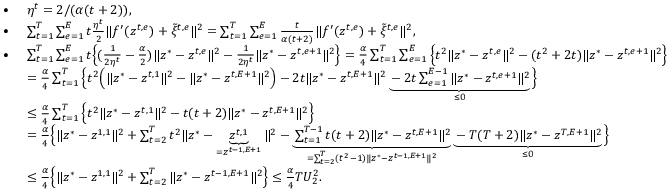<formula> <loc_0><loc_0><loc_500><loc_500>\begin{array} { r l } { \bullet \ } & { \eta ^ { t } = 2 / ( \alpha ( t + 2 ) ) , } \\ { \bullet \ } & { \sum _ { t = 1 } ^ { T } \sum _ { e = 1 } ^ { E } t \frac { \eta ^ { t } } { 2 } \| f ^ { \prime } ( z ^ { t , e } ) + \tilde { \xi } ^ { t , e } \| ^ { 2 } = \sum _ { t = 1 } ^ { T } \sum _ { e = 1 } ^ { E } \frac { t } { \alpha ( t + 2 ) } \| f ^ { \prime } ( z ^ { t , e } ) + \tilde { \xi } ^ { t , e } \| ^ { 2 } , } \\ { \bullet \ } & { \sum _ { t = 1 } ^ { T } \sum _ { e = 1 } ^ { E } t \left \{ ( \frac { 1 } { 2 \eta ^ { t } } - \frac { \alpha } { 2 } ) \| z ^ { * } - z ^ { t , e } \| ^ { 2 } - \frac { 1 } { 2 \eta ^ { t } } \| z ^ { * } - z ^ { t , e + 1 } \| ^ { 2 } \right \} = \frac { \alpha } { 4 } \sum _ { t = 1 } ^ { T } \sum _ { e = 1 } ^ { E } \left \{ t ^ { 2 } \| z ^ { * } - z ^ { t , e } \| ^ { 2 } - ( t ^ { 2 } + 2 t ) \| z ^ { * } - z ^ { t , e + 1 } \| ^ { 2 } \right \} } \\ & { = \frac { \alpha } { 4 } \sum _ { t = 1 } ^ { T } \left \{ t ^ { 2 } \left ( \| z ^ { * } - z ^ { t , 1 } \| ^ { 2 } - \| z ^ { * } - z ^ { t , E + 1 } \| ^ { 2 } \right ) - 2 t \| z ^ { * } - z ^ { t , E + 1 } \| ^ { 2 } \underbrace { - 2 t \sum _ { e = 1 } ^ { E - 1 } \| z ^ { * } - z ^ { t , e + 1 } \| ^ { 2 } } _ { \leq 0 } \right \} } \\ & { \leq \frac { \alpha } { 4 } \sum _ { t = 1 } ^ { T } \left \{ t ^ { 2 } \| z ^ { * } - z ^ { t , 1 } \| ^ { 2 } - t ( t + 2 ) \| z ^ { * } - z ^ { t , E + 1 } \| ^ { 2 } \right \} } \\ & { = \frac { \alpha } { 4 } \left \{ \| z ^ { * } - z ^ { 1 , 1 } \| ^ { 2 } + \sum _ { t = 2 } ^ { T } t ^ { 2 } \| z ^ { * } - \underbrace { z ^ { t , 1 } } _ { = z ^ { t - 1 , E + 1 } } \| ^ { 2 } - \underbrace { \sum _ { t = 1 } ^ { T - 1 } t ( t + 2 ) \| z ^ { * } - z ^ { t , E + 1 } \| ^ { 2 } } _ { = \sum _ { t = 2 } ^ { T } ( t ^ { 2 } - 1 ) \| z ^ { * } - z ^ { t - 1 , E + 1 } \| ^ { 2 } } \underbrace { - T ( T + 2 ) \| z ^ { * } - z ^ { T , E + 1 } \| ^ { 2 } } _ { \leq 0 } \right \} } \\ & { \leq \frac { \alpha } { 4 } \left \{ \| z ^ { * } - z ^ { 1 , 1 } \| ^ { 2 } + \sum _ { t = 2 } ^ { T } \| z ^ { * } - z ^ { t - 1 , E + 1 } \| ^ { 2 } \right \} \leq \frac { \alpha } { 4 } T U _ { 2 } ^ { 2 } . } \end{array}</formula> 